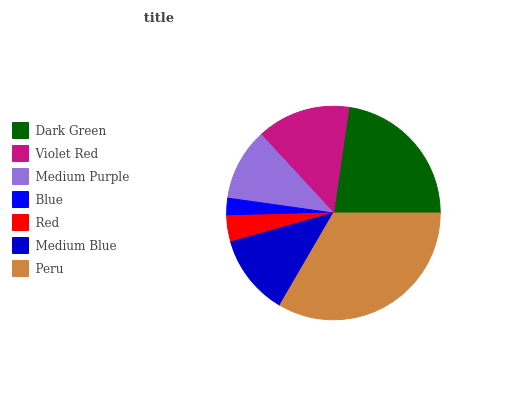Is Blue the minimum?
Answer yes or no. Yes. Is Peru the maximum?
Answer yes or no. Yes. Is Violet Red the minimum?
Answer yes or no. No. Is Violet Red the maximum?
Answer yes or no. No. Is Dark Green greater than Violet Red?
Answer yes or no. Yes. Is Violet Red less than Dark Green?
Answer yes or no. Yes. Is Violet Red greater than Dark Green?
Answer yes or no. No. Is Dark Green less than Violet Red?
Answer yes or no. No. Is Medium Blue the high median?
Answer yes or no. Yes. Is Medium Blue the low median?
Answer yes or no. Yes. Is Blue the high median?
Answer yes or no. No. Is Red the low median?
Answer yes or no. No. 